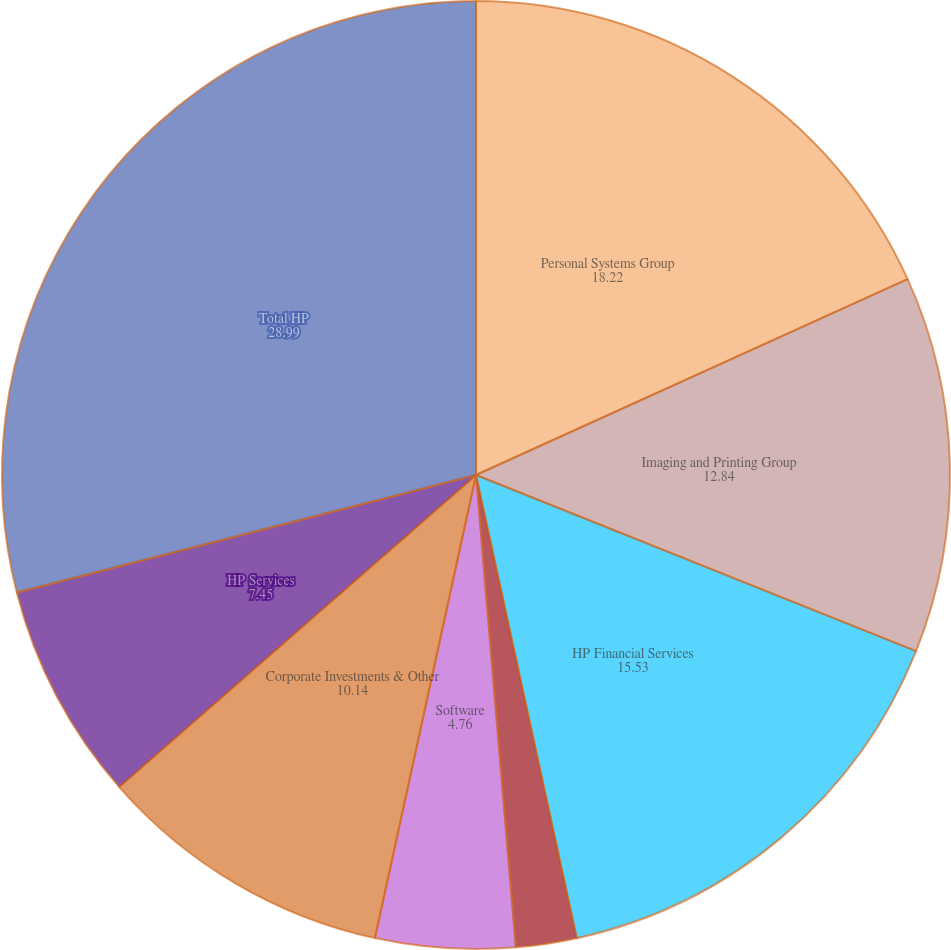Convert chart. <chart><loc_0><loc_0><loc_500><loc_500><pie_chart><fcel>Personal Systems Group<fcel>Imaging and Printing Group<fcel>HP Financial Services<fcel>Enterprise Storage and Servers<fcel>Software<fcel>Corporate Investments & Other<fcel>HP Services<fcel>Total HP<nl><fcel>18.22%<fcel>12.84%<fcel>15.53%<fcel>2.07%<fcel>4.76%<fcel>10.14%<fcel>7.45%<fcel>28.99%<nl></chart> 